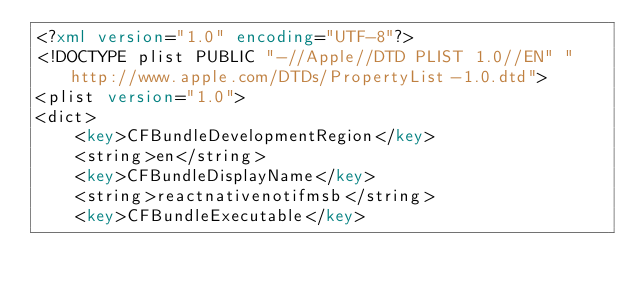Convert code to text. <code><loc_0><loc_0><loc_500><loc_500><_XML_><?xml version="1.0" encoding="UTF-8"?>
<!DOCTYPE plist PUBLIC "-//Apple//DTD PLIST 1.0//EN" "http://www.apple.com/DTDs/PropertyList-1.0.dtd">
<plist version="1.0">
<dict>
	<key>CFBundleDevelopmentRegion</key>
	<string>en</string>
	<key>CFBundleDisplayName</key>
	<string>reactnativenotifmsb</string>
	<key>CFBundleExecutable</key></code> 